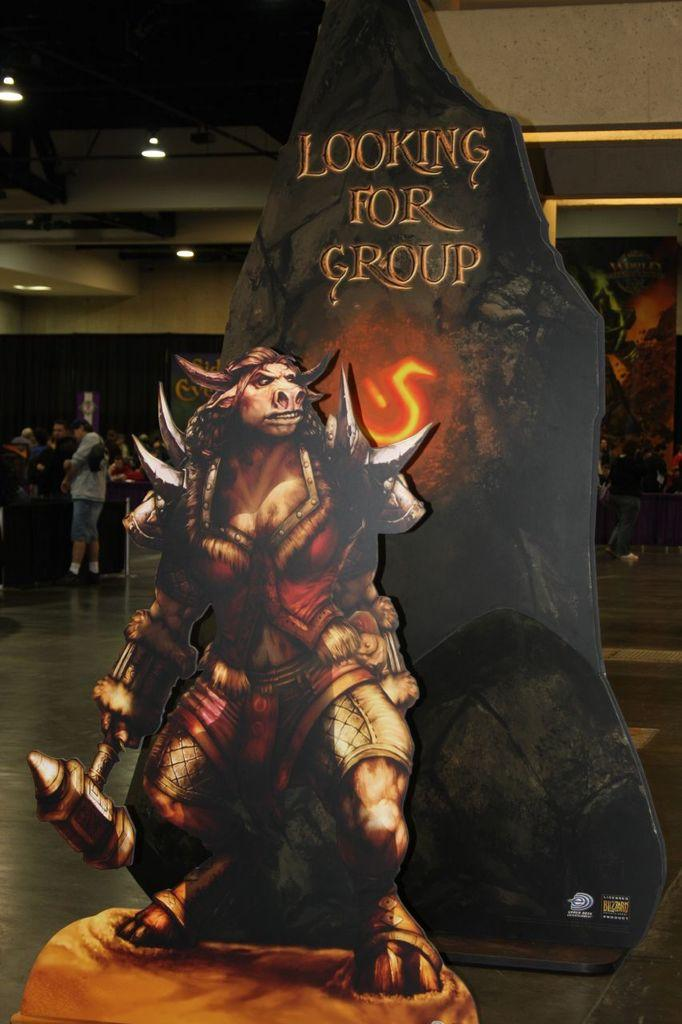What is the main subject of the poster in the image? There is a poster of a monster in the image. What else is present behind the poster? There is text behind the poster. Can you describe the background of the image? There is a group of people in the background of the image. What type of whip is being used by the monster in the image? There is no whip present in the image, and the monster is not depicted as using any object. 